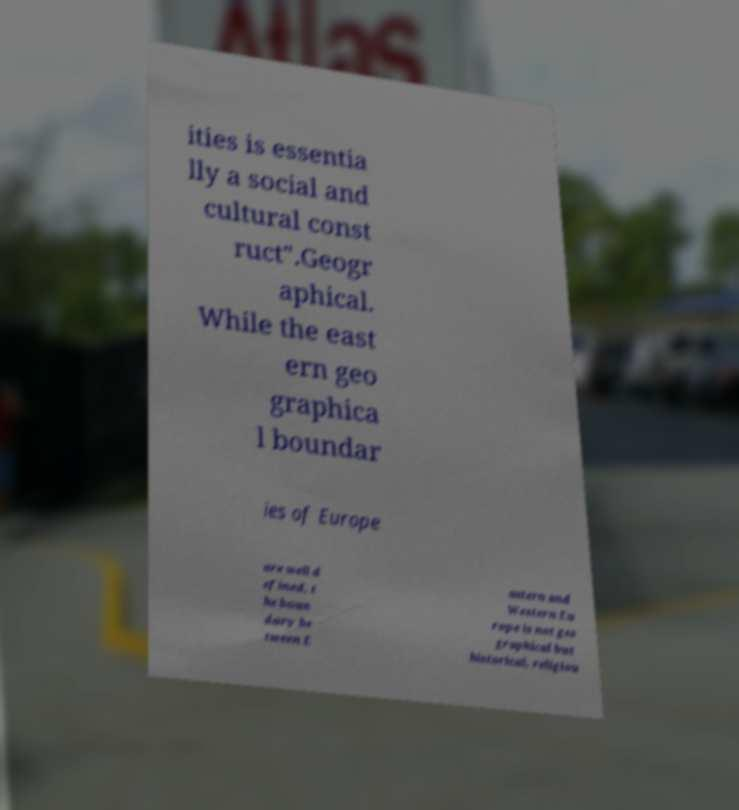I need the written content from this picture converted into text. Can you do that? ities is essentia lly a social and cultural const ruct".Geogr aphical. While the east ern geo graphica l boundar ies of Europe are well d efined, t he boun dary be tween E astern and Western Eu rope is not geo graphical but historical, religiou 